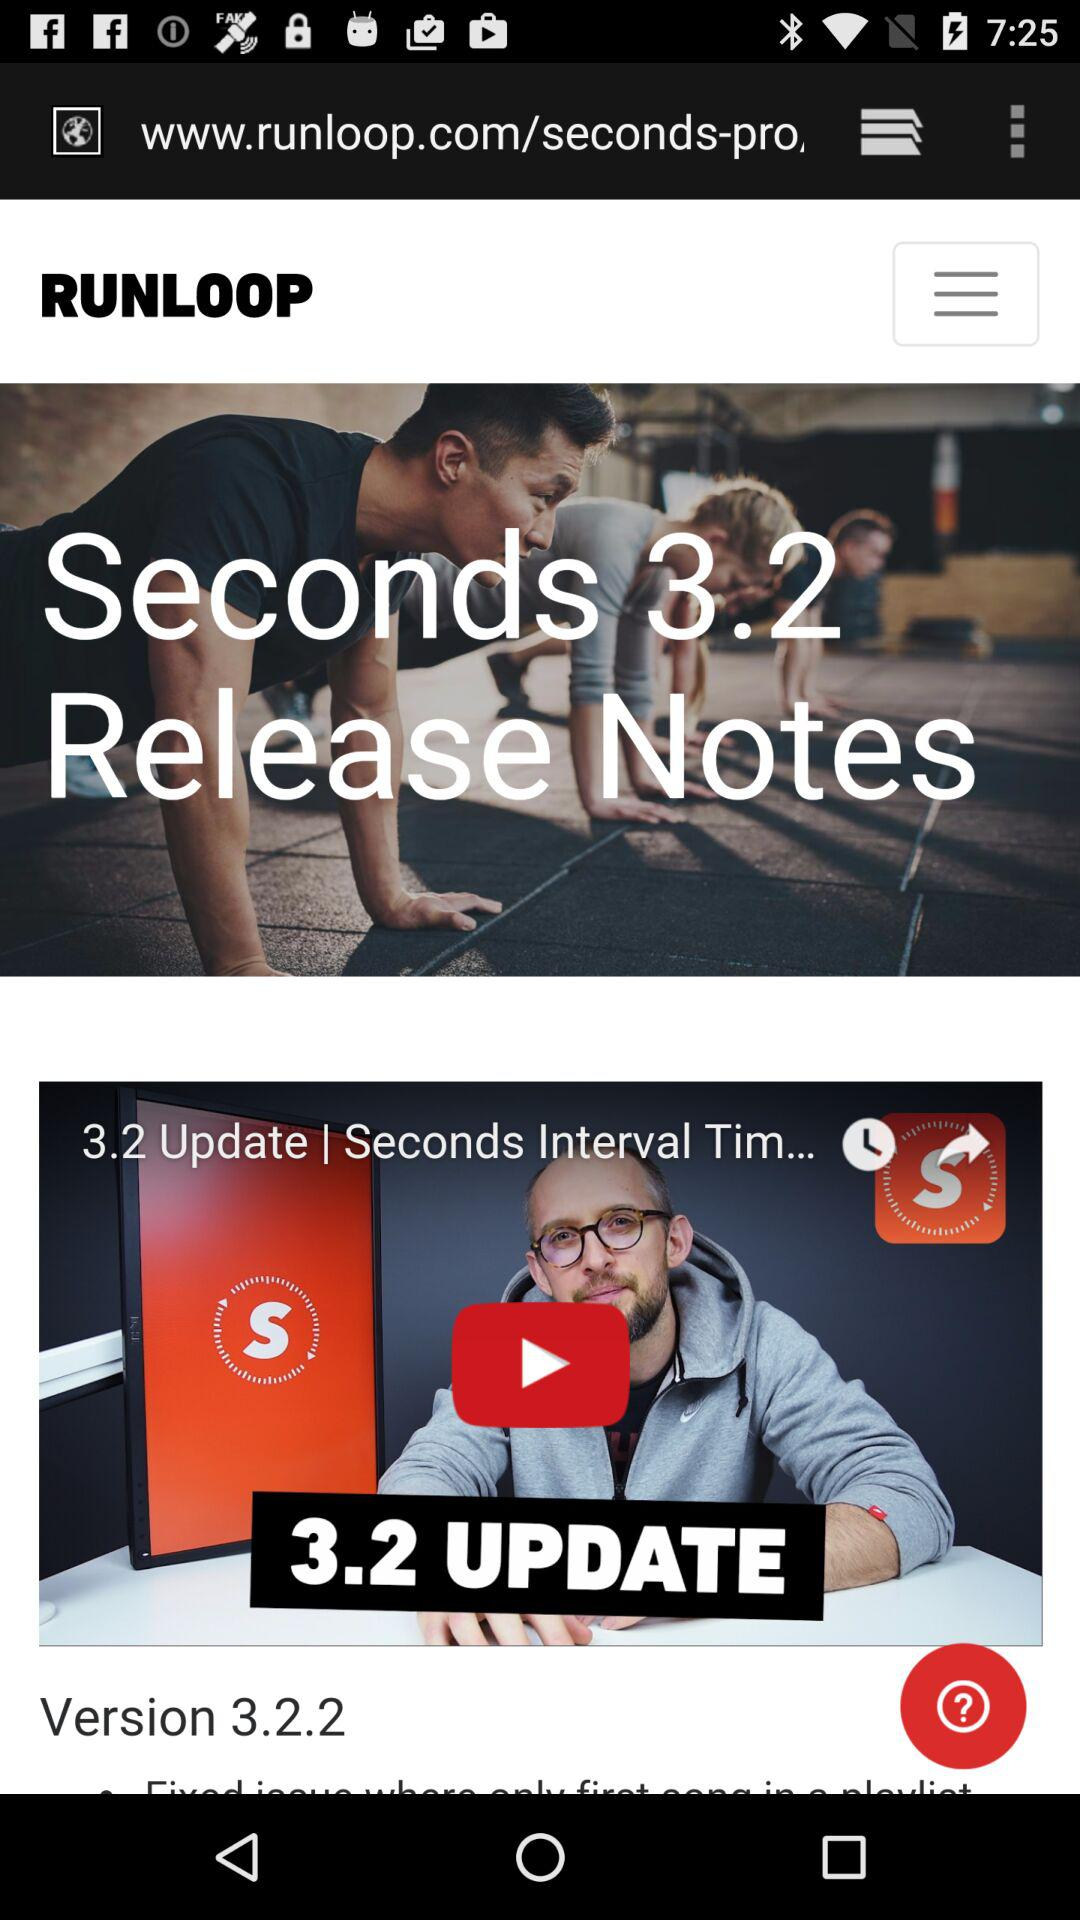What is the version? The version is 3.2.2. 